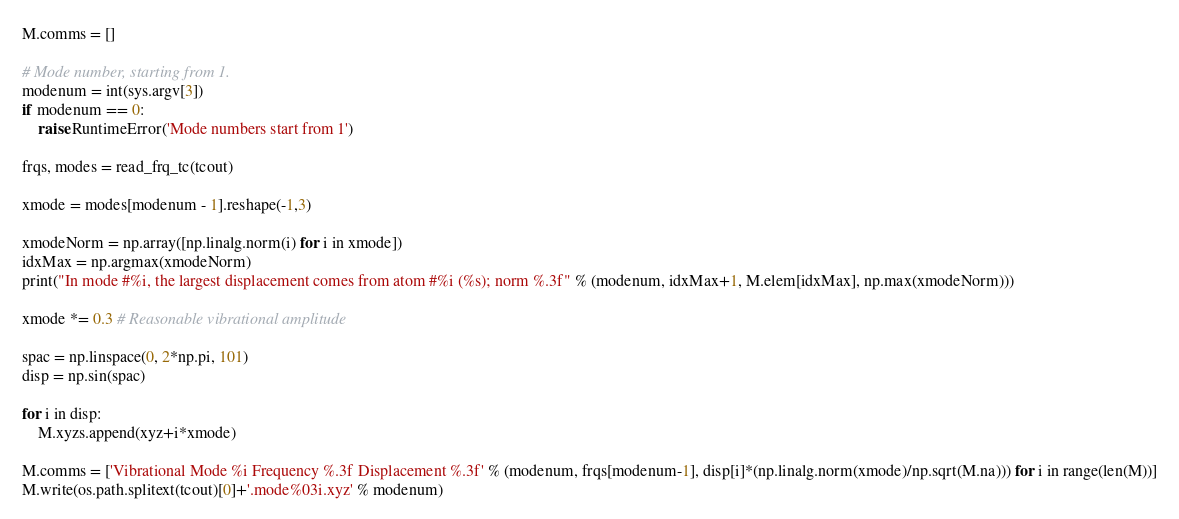<code> <loc_0><loc_0><loc_500><loc_500><_Python_>M.comms = []

# Mode number, starting from 1.
modenum = int(sys.argv[3])
if modenum == 0:
    raise RuntimeError('Mode numbers start from 1')

frqs, modes = read_frq_tc(tcout)

xmode = modes[modenum - 1].reshape(-1,3)

xmodeNorm = np.array([np.linalg.norm(i) for i in xmode])
idxMax = np.argmax(xmodeNorm)
print("In mode #%i, the largest displacement comes from atom #%i (%s); norm %.3f" % (modenum, idxMax+1, M.elem[idxMax], np.max(xmodeNorm)))

xmode *= 0.3 # Reasonable vibrational amplitude

spac = np.linspace(0, 2*np.pi, 101)
disp = np.sin(spac)

for i in disp:
    M.xyzs.append(xyz+i*xmode)

M.comms = ['Vibrational Mode %i Frequency %.3f Displacement %.3f' % (modenum, frqs[modenum-1], disp[i]*(np.linalg.norm(xmode)/np.sqrt(M.na))) for i in range(len(M))]
M.write(os.path.splitext(tcout)[0]+'.mode%03i.xyz' % modenum)
</code> 